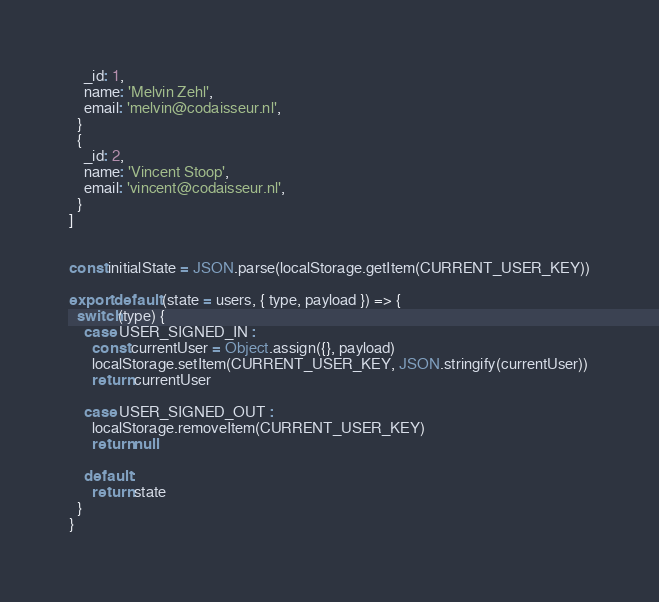Convert code to text. <code><loc_0><loc_0><loc_500><loc_500><_JavaScript_>    _id: 1,
    name: 'Melvin Zehl',
    email: 'melvin@codaisseur.nl',
  }
  {
    _id: 2,
    name: 'Vincent Stoop',
    email: 'vincent@codaisseur.nl',
  }
]


const initialState = JSON.parse(localStorage.getItem(CURRENT_USER_KEY))

export default (state = users, { type, payload }) => {
  switch(type) {
    case USER_SIGNED_IN :
      const currentUser = Object.assign({}, payload)
      localStorage.setItem(CURRENT_USER_KEY, JSON.stringify(currentUser))
      return currentUser

    case USER_SIGNED_OUT :
      localStorage.removeItem(CURRENT_USER_KEY)
      return null

    default :
      return state
  }
}
</code> 